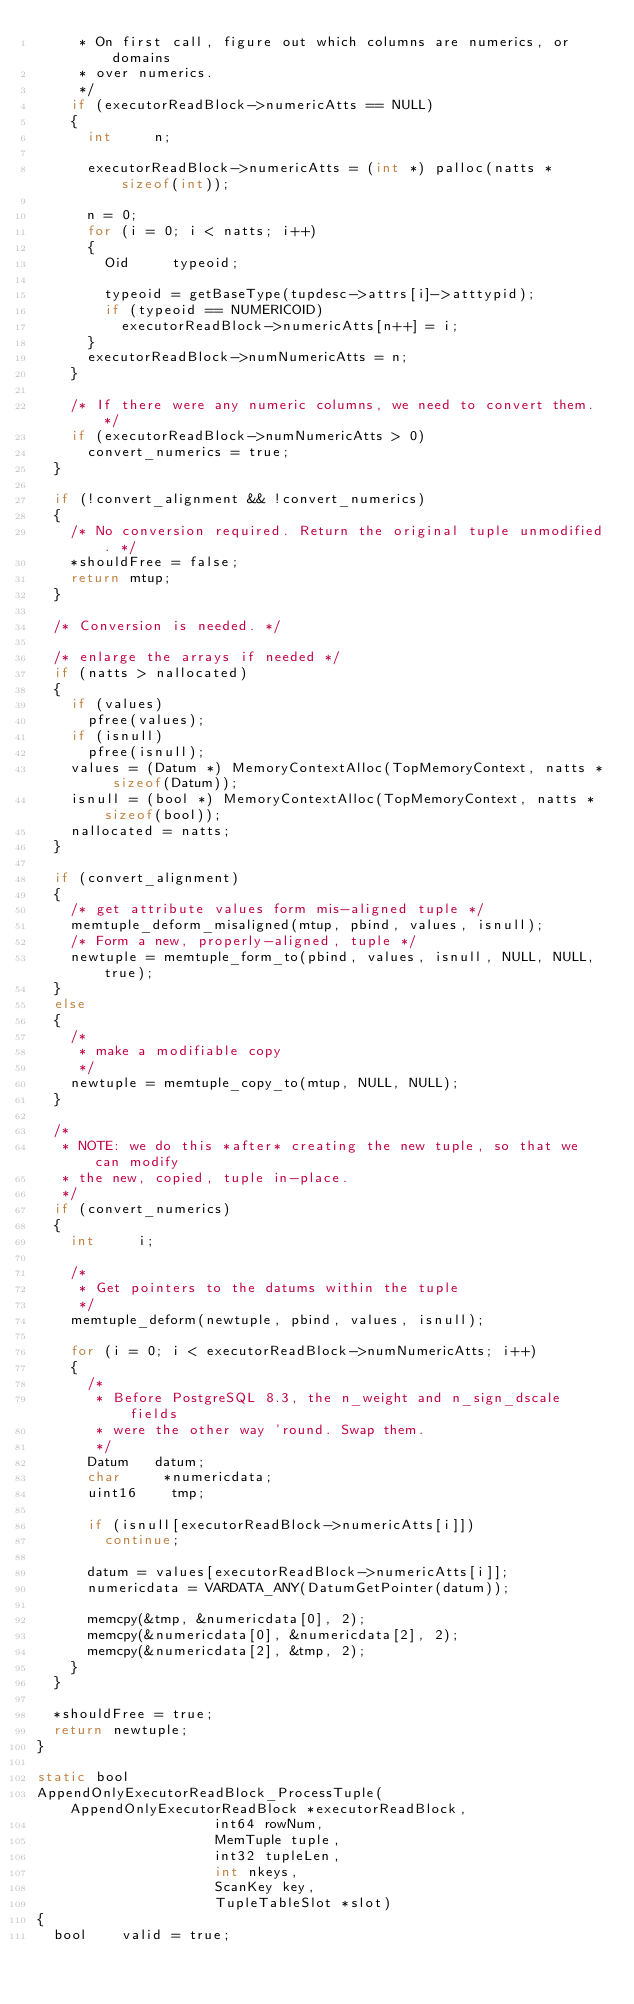Convert code to text. <code><loc_0><loc_0><loc_500><loc_500><_C_>		 * On first call, figure out which columns are numerics, or domains
		 * over numerics.
		 */
		if (executorReadBlock->numericAtts == NULL)
		{
			int			n;

			executorReadBlock->numericAtts = (int *) palloc(natts * sizeof(int));

			n = 0;
			for (i = 0; i < natts; i++)
			{
				Oid			typeoid;

				typeoid = getBaseType(tupdesc->attrs[i]->atttypid);
				if (typeoid == NUMERICOID)
					executorReadBlock->numericAtts[n++] = i;
			}
			executorReadBlock->numNumericAtts = n;
		}

		/* If there were any numeric columns, we need to convert them. */
		if (executorReadBlock->numNumericAtts > 0)
			convert_numerics = true;
	}

	if (!convert_alignment && !convert_numerics)
	{
		/* No conversion required. Return the original tuple unmodified. */
		*shouldFree = false;
		return mtup;
	}

	/* Conversion is needed. */

	/* enlarge the arrays if needed */
	if (natts > nallocated)
	{
		if (values)
			pfree(values);
		if (isnull)
			pfree(isnull);
		values = (Datum *) MemoryContextAlloc(TopMemoryContext, natts * sizeof(Datum));
		isnull = (bool *) MemoryContextAlloc(TopMemoryContext, natts * sizeof(bool));
		nallocated = natts;
	}

	if (convert_alignment)
	{
		/* get attribute values form mis-aligned tuple */
		memtuple_deform_misaligned(mtup, pbind, values, isnull);
		/* Form a new, properly-aligned, tuple */
		newtuple = memtuple_form_to(pbind, values, isnull, NULL, NULL, true);
	}
	else
	{
		/*
		 * make a modifiable copy
		 */
		newtuple = memtuple_copy_to(mtup, NULL, NULL);
	}

	/*
	 * NOTE: we do this *after* creating the new tuple, so that we can modify
	 * the new, copied, tuple in-place.
	 */
	if (convert_numerics)
	{
		int			i;

		/*
		 * Get pointers to the datums within the tuple
		 */
		memtuple_deform(newtuple, pbind, values, isnull);

		for (i = 0; i < executorReadBlock->numNumericAtts; i++)
		{
			/*
			 * Before PostgreSQL 8.3, the n_weight and n_sign_dscale fields
			 * were the other way 'round. Swap them.
			 */
			Datum		datum;
			char	   *numericdata;
			uint16		tmp;

			if (isnull[executorReadBlock->numericAtts[i]])
				continue;

			datum = values[executorReadBlock->numericAtts[i]];
			numericdata = VARDATA_ANY(DatumGetPointer(datum));

			memcpy(&tmp, &numericdata[0], 2);
			memcpy(&numericdata[0], &numericdata[2], 2);
			memcpy(&numericdata[2], &tmp, 2);
		}
	}

	*shouldFree = true;
	return newtuple;
}

static bool
AppendOnlyExecutorReadBlock_ProcessTuple(AppendOnlyExecutorReadBlock *executorReadBlock,
										 int64 rowNum,
										 MemTuple tuple,
										 int32 tupleLen,
										 int nkeys,
										 ScanKey key,
										 TupleTableSlot *slot)
{
	bool		valid = true;
</code> 